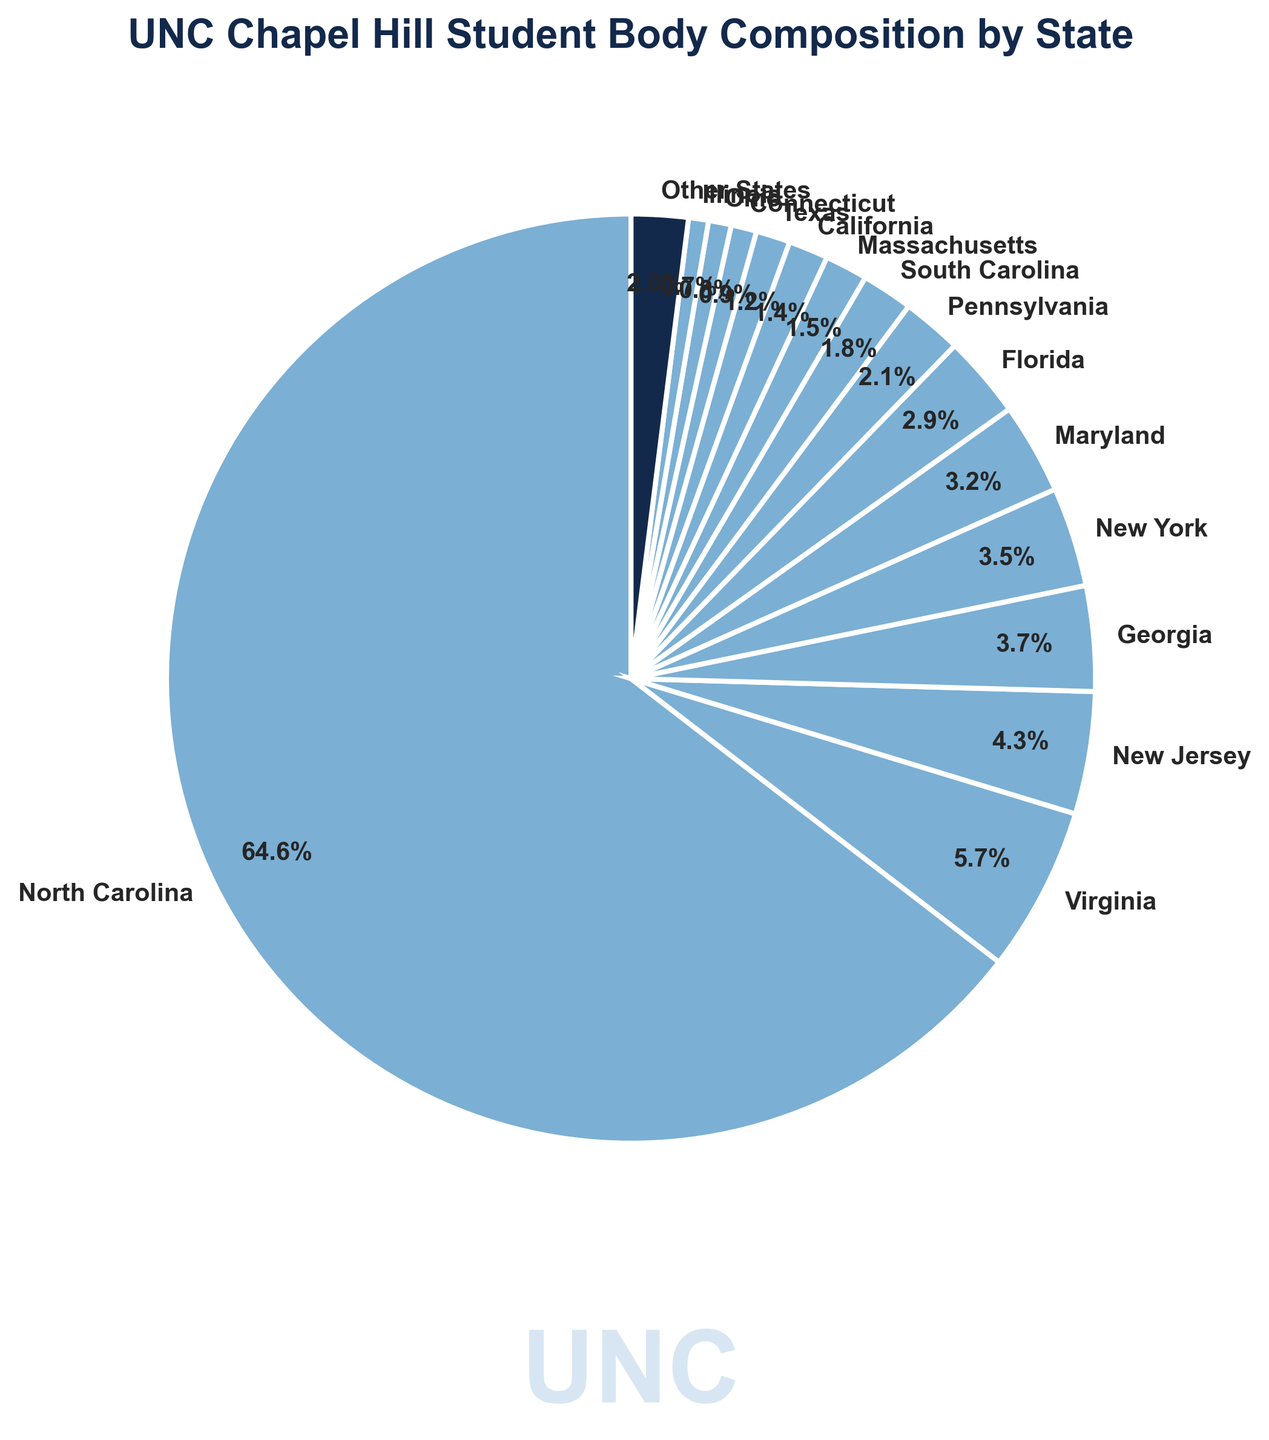What state has the highest percentage of students at UNC Chapel Hill? The largest wedge in the pie chart represents North Carolina, with the label showing the percentage.
Answer: North Carolina Which two states have the closest percentages of students? Comparing the percentages, New York (3.5%) and Maryland (3.2%) are the closest with a difference of 0.3%.
Answer: New York and Maryland What is the combined percentage of students from Virginia and New Jersey? Summing up the percentages for Virginia (5.8%) and New Jersey (4.3%) gives 10.1%.
Answer: 10.1% Is the percentage of students from South Carolina greater than that from Texas? The pie chart shows South Carolina at 1.8% and Texas at 1.2%, so South Carolina's percentage is greater.
Answer: Yes What is the sum of the percentages for states contributing less than 2% each? Adding the percentages for South Carolina (1.8%), Massachusetts (1.5%), California (1.4%), Texas (1.2%), Connecticut (0.9%), Ohio (0.8%), Illinois (0.7%), and Other States (2.0%) gives a total of 10.3%.
Answer: 10.3% Which state has the smallest wedge and what is its percentage? The smallest wedge represents Illinois with a percentage of 0.7%.
Answer: Illinois with 0.7% How does the percentage of students from Florida compare to those from Pennsylvania? Comparing the pie chart, Florida has 2.9% and Pennsylvania has 2.1%, so Florida has a higher percentage.
Answer: Florida has a higher percentage What's the combined percentage of students from the top three states? Summing up North Carolina (65.2%), Virginia (5.8%), and New Jersey (4.3%) gives 75.3%.
Answer: 75.3% Which state has a percentage closest to 3%? Maryland's wedge shows 3.2%, which is closest to 3%.
Answer: Maryland What's the difference in percentage between students from New York and students from Massachusetts? New York has 3.5% and Massachusetts has 1.5%, so the difference is calculated as 3.5% - 1.5% = 2%.
Answer: 2% 